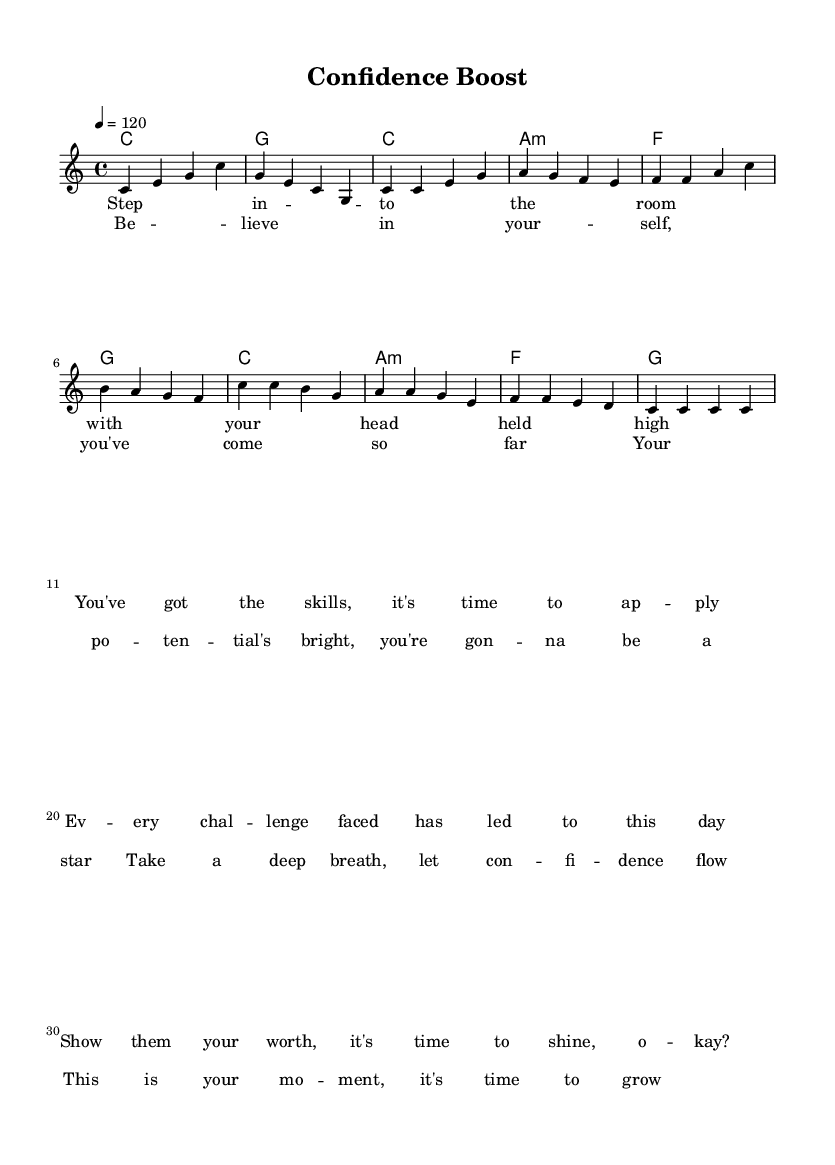What is the key signature of this music? The key signature is C major, which has no sharps or flats.
Answer: C major What is the time signature of this piece? The time signature is found at the beginning of the sheet music, and it’s listed as 4/4, indicating four beats per measure.
Answer: 4/4 What is the tempo marking? The tempo marking is given at the start and reads "4 = 120," meaning the quarter note is set at a tempo of 120 beats per minute.
Answer: 120 How many measures are in the verse section? By counting the measures in the verse lyrics, we see there are four measures total in the verse section.
Answer: 4 What type of chord follows the intro? The chord after the intro chord progression is in the verse, and the first chord there is C major.
Answer: C major In what style is the music composed? The overall composition style blends upbeat pop melodies with motivational speech themes, as indicated by the lyrics and the lively tempo.
Answer: Fusion What refrain is repeated between the verses and choruses? The main refrain that emphasizes self-belief and growth is captured in the chorus lyrics which are repeated after the verses.
Answer: Chorus 